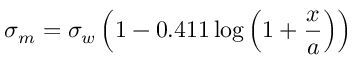<formula> <loc_0><loc_0><loc_500><loc_500>\sigma _ { m } = \sigma _ { w } \left ( 1 - 0 . 4 1 1 \log \left ( 1 + { \frac { x } { a } } \right ) \right )</formula> 